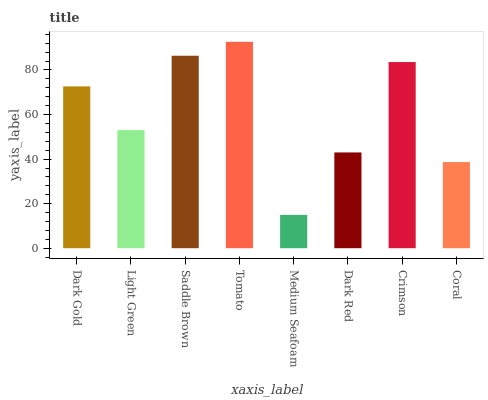Is Medium Seafoam the minimum?
Answer yes or no. Yes. Is Tomato the maximum?
Answer yes or no. Yes. Is Light Green the minimum?
Answer yes or no. No. Is Light Green the maximum?
Answer yes or no. No. Is Dark Gold greater than Light Green?
Answer yes or no. Yes. Is Light Green less than Dark Gold?
Answer yes or no. Yes. Is Light Green greater than Dark Gold?
Answer yes or no. No. Is Dark Gold less than Light Green?
Answer yes or no. No. Is Dark Gold the high median?
Answer yes or no. Yes. Is Light Green the low median?
Answer yes or no. Yes. Is Dark Red the high median?
Answer yes or no. No. Is Dark Red the low median?
Answer yes or no. No. 